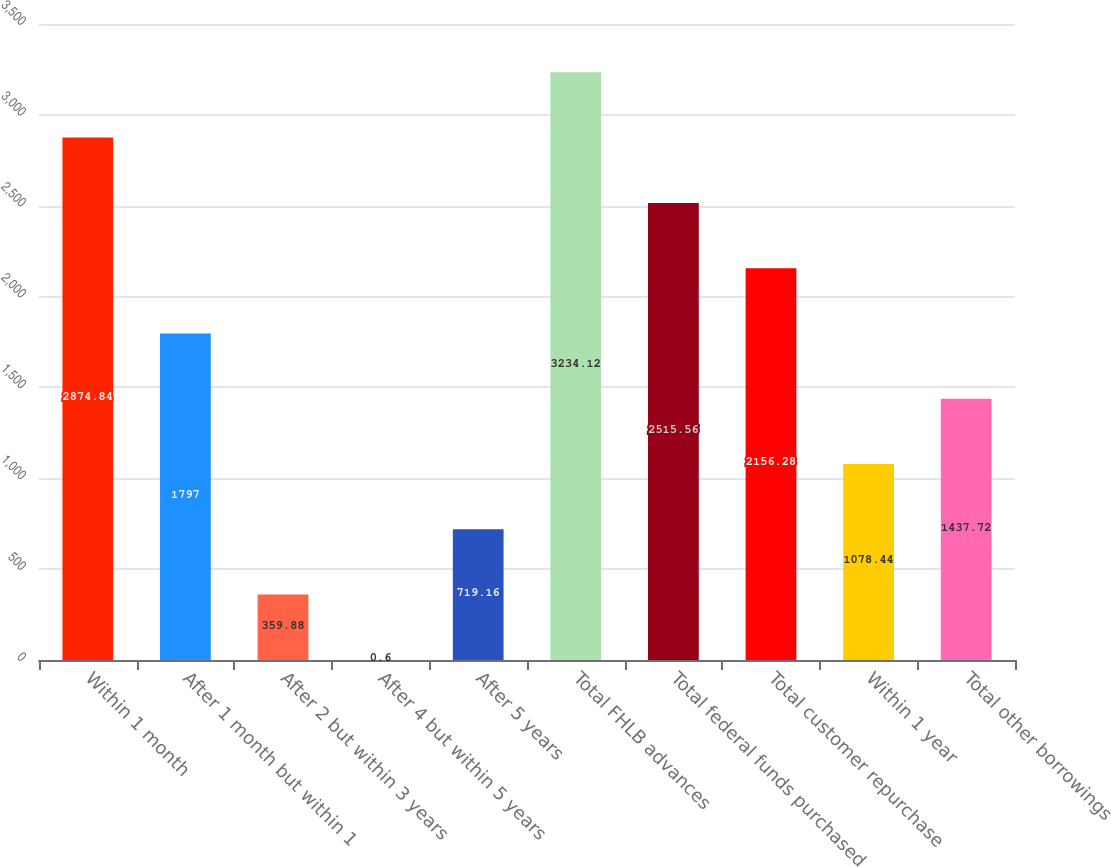Convert chart to OTSL. <chart><loc_0><loc_0><loc_500><loc_500><bar_chart><fcel>Within 1 month<fcel>After 1 month but within 1<fcel>After 2 but within 3 years<fcel>After 4 but within 5 years<fcel>After 5 years<fcel>Total FHLB advances<fcel>Total federal funds purchased<fcel>Total customer repurchase<fcel>Within 1 year<fcel>Total other borrowings<nl><fcel>2874.84<fcel>1797<fcel>359.88<fcel>0.6<fcel>719.16<fcel>3234.12<fcel>2515.56<fcel>2156.28<fcel>1078.44<fcel>1437.72<nl></chart> 